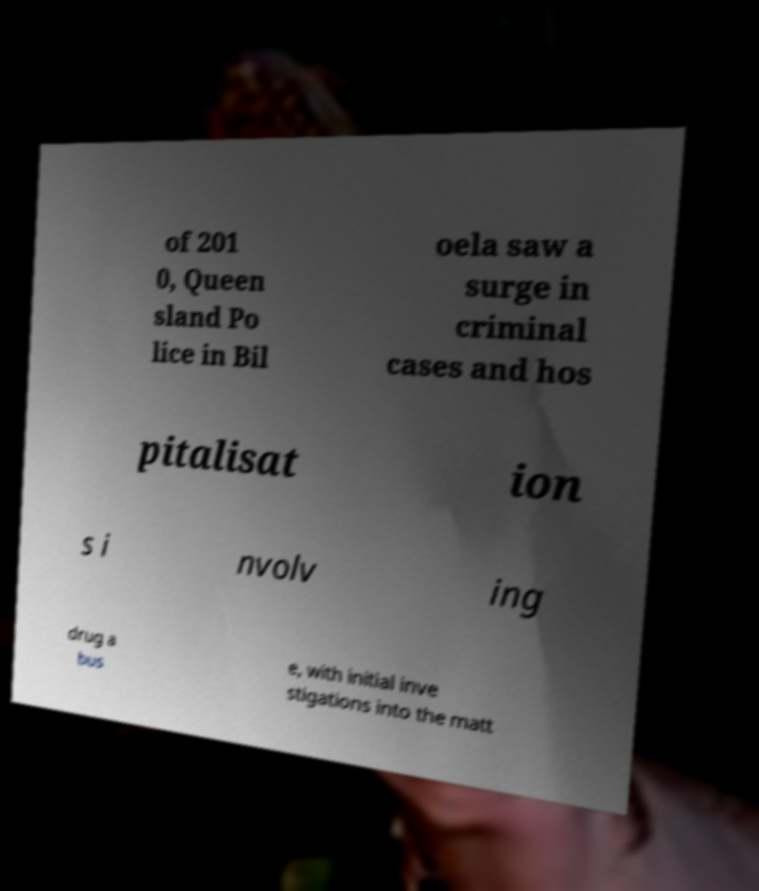Could you extract and type out the text from this image? of 201 0, Queen sland Po lice in Bil oela saw a surge in criminal cases and hos pitalisat ion s i nvolv ing drug a bus e, with initial inve stigations into the matt 